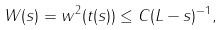<formula> <loc_0><loc_0><loc_500><loc_500>W ( s ) = w ^ { 2 } ( t ( s ) ) \leq C ( L - s ) ^ { - 1 } ,</formula> 